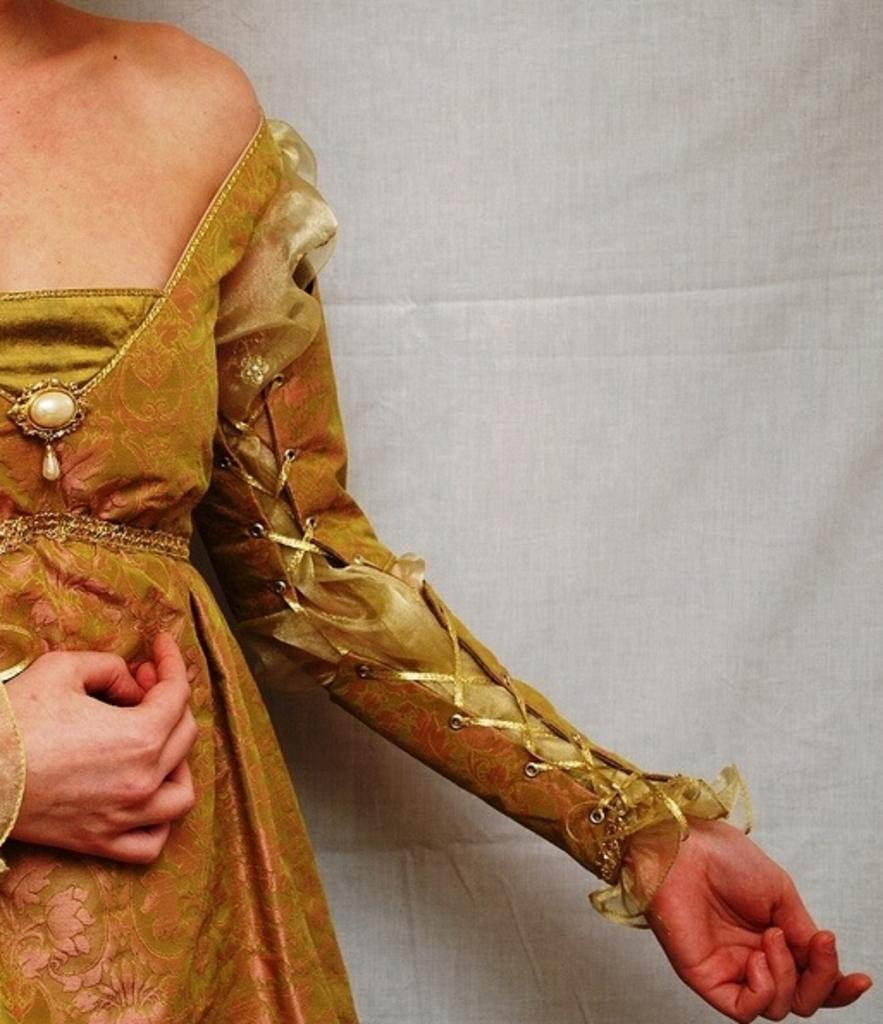Who is the main subject in the image? There is a woman in the image. What is the woman wearing? The woman is wearing a brown dress. How is the dress described? The dress is described as beautiful. What part of the woman is visible in the image? The image only shows half of the woman. What can be seen in the background of the image? There is a white fabric curtain in the background of the image. What type of prose is the woman reading in the image? There is no indication in the image that the woman is reading any prose. Can you recall any memories the woman might have while wearing the brown dress? We cannot recall any memories the woman might have, as the image only provides a visual representation and does not include any information about the woman's thoughts or experiences. 